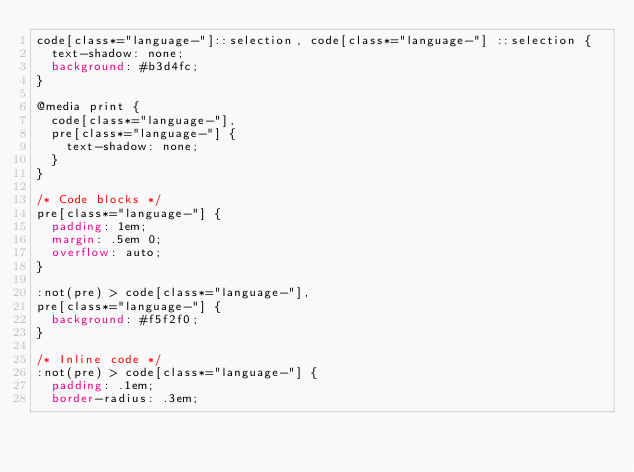<code> <loc_0><loc_0><loc_500><loc_500><_CSS_>code[class*="language-"]::selection, code[class*="language-"] ::selection {
	text-shadow: none;
	background: #b3d4fc;
}

@media print {
	code[class*="language-"],
	pre[class*="language-"] {
		text-shadow: none;
	}
}

/* Code blocks */
pre[class*="language-"] {
	padding: 1em;
	margin: .5em 0;
	overflow: auto;
}

:not(pre) > code[class*="language-"],
pre[class*="language-"] {
	background: #f5f2f0;
}

/* Inline code */
:not(pre) > code[class*="language-"] {
	padding: .1em;
	border-radius: .3em;</code> 